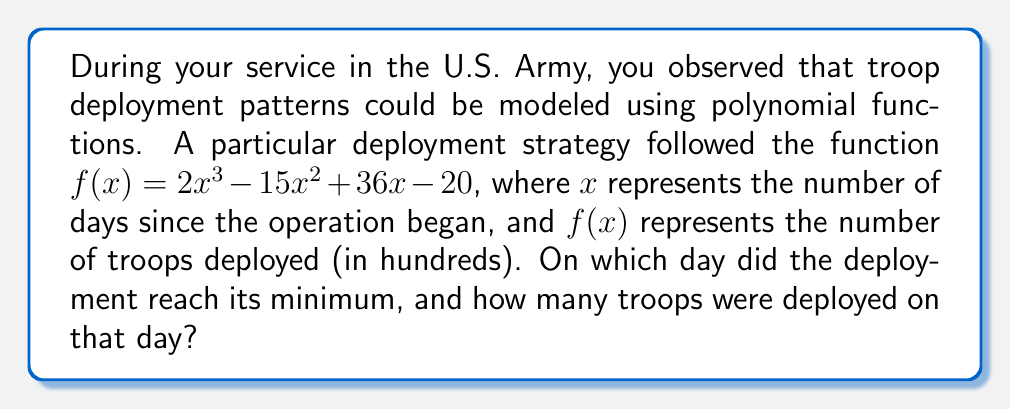Can you answer this question? To solve this problem, we'll follow these steps:

1) The minimum of a function occurs where its derivative equals zero. Let's find the derivative of $f(x)$:

   $f'(x) = 6x^2 - 30x + 36$

2) Set $f'(x) = 0$ and solve for $x$:

   $6x^2 - 30x + 36 = 0$

3) This is a quadratic equation. We can solve it using the quadratic formula:
   $x = \frac{-b \pm \sqrt{b^2 - 4ac}}{2a}$

   Where $a = 6$, $b = -30$, and $c = 36$

4) Plugging in these values:

   $x = \frac{30 \pm \sqrt{900 - 864}}{12} = \frac{30 \pm \sqrt{36}}{12} = \frac{30 \pm 6}{12}$

5) This gives us two solutions:

   $x_1 = \frac{30 + 6}{12} = 3$ and $x_2 = \frac{30 - 6}{12} = 2$

6) To determine which of these is the minimum, we can check the second derivative:

   $f''(x) = 12x - 30$

   At $x = 2$: $f''(2) = 12(2) - 30 = -6$ (negative, so this is a maximum)
   At $x = 3$: $f''(3) = 12(3) - 30 = 6$ (positive, so this is a minimum)

7) Therefore, the minimum occurs at $x = 3$, or on the 3rd day.

8) To find the number of troops deployed on that day, we plug $x = 3$ into the original function:

   $f(3) = 2(3^3) - 15(3^2) + 36(3) - 20$
         $= 54 - 135 + 108 - 20$
         $= 7$

9) Remember that $f(x)$ represents troops in hundreds, so 7 here means 700 troops.
Answer: Day 3; 700 troops 